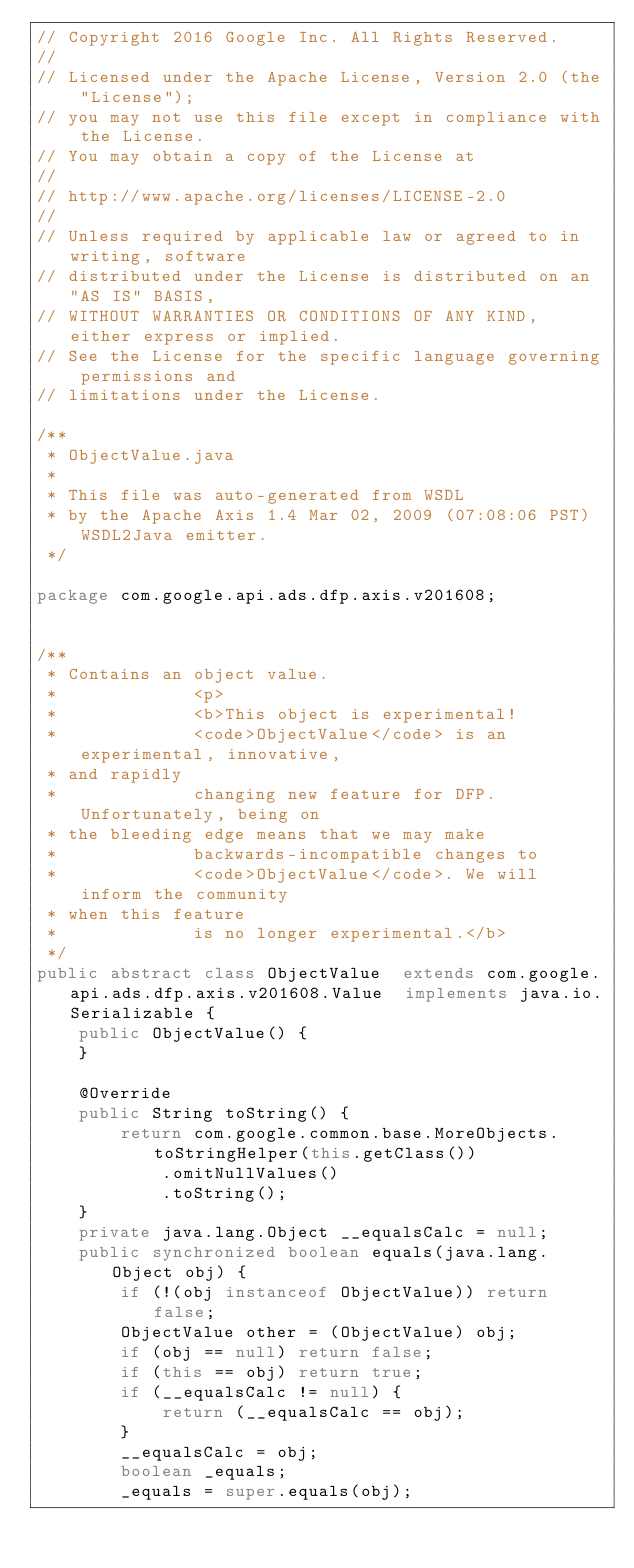<code> <loc_0><loc_0><loc_500><loc_500><_Java_>// Copyright 2016 Google Inc. All Rights Reserved.
//
// Licensed under the Apache License, Version 2.0 (the "License");
// you may not use this file except in compliance with the License.
// You may obtain a copy of the License at
//
// http://www.apache.org/licenses/LICENSE-2.0
//
// Unless required by applicable law or agreed to in writing, software
// distributed under the License is distributed on an "AS IS" BASIS,
// WITHOUT WARRANTIES OR CONDITIONS OF ANY KIND, either express or implied.
// See the License for the specific language governing permissions and
// limitations under the License.

/**
 * ObjectValue.java
 *
 * This file was auto-generated from WSDL
 * by the Apache Axis 1.4 Mar 02, 2009 (07:08:06 PST) WSDL2Java emitter.
 */

package com.google.api.ads.dfp.axis.v201608;


/**
 * Contains an object value.
 *             <p>
 *             <b>This object is experimental!
 *             <code>ObjectValue</code> is an experimental, innovative,
 * and rapidly
 *             changing new feature for DFP. Unfortunately, being on
 * the bleeding edge means that we may make
 *             backwards-incompatible changes to
 *             <code>ObjectValue</code>. We will inform the community
 * when this feature
 *             is no longer experimental.</b>
 */
public abstract class ObjectValue  extends com.google.api.ads.dfp.axis.v201608.Value  implements java.io.Serializable {
    public ObjectValue() {
    }

    @Override
    public String toString() {
        return com.google.common.base.MoreObjects.toStringHelper(this.getClass())
            .omitNullValues()
            .toString();
    }
    private java.lang.Object __equalsCalc = null;
    public synchronized boolean equals(java.lang.Object obj) {
        if (!(obj instanceof ObjectValue)) return false;
        ObjectValue other = (ObjectValue) obj;
        if (obj == null) return false;
        if (this == obj) return true;
        if (__equalsCalc != null) {
            return (__equalsCalc == obj);
        }
        __equalsCalc = obj;
        boolean _equals;
        _equals = super.equals(obj);</code> 